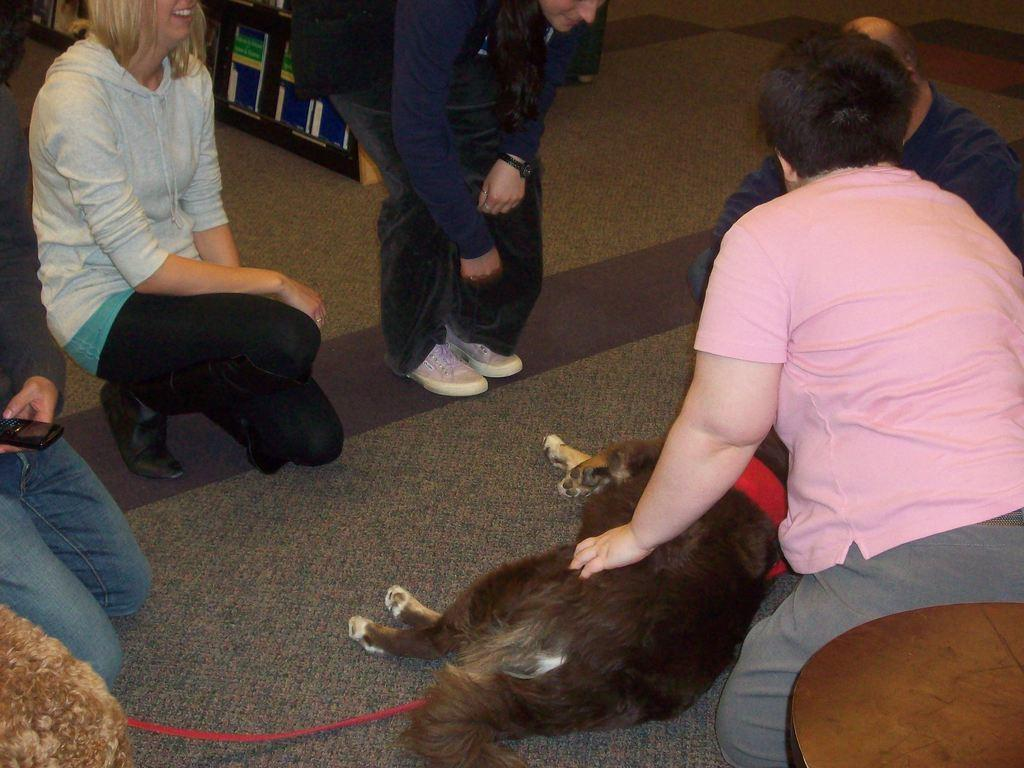What type of animal is in the image? There is a dog in the image. What position is the dog in? The dog is lying on the floor. Are there any humans in the image? Yes, there are people around the dog. What type of currency is being exchanged between the dog and the people in the image? There is no currency exchange depicted in the image; it features a dog lying on the floor with people around it. 